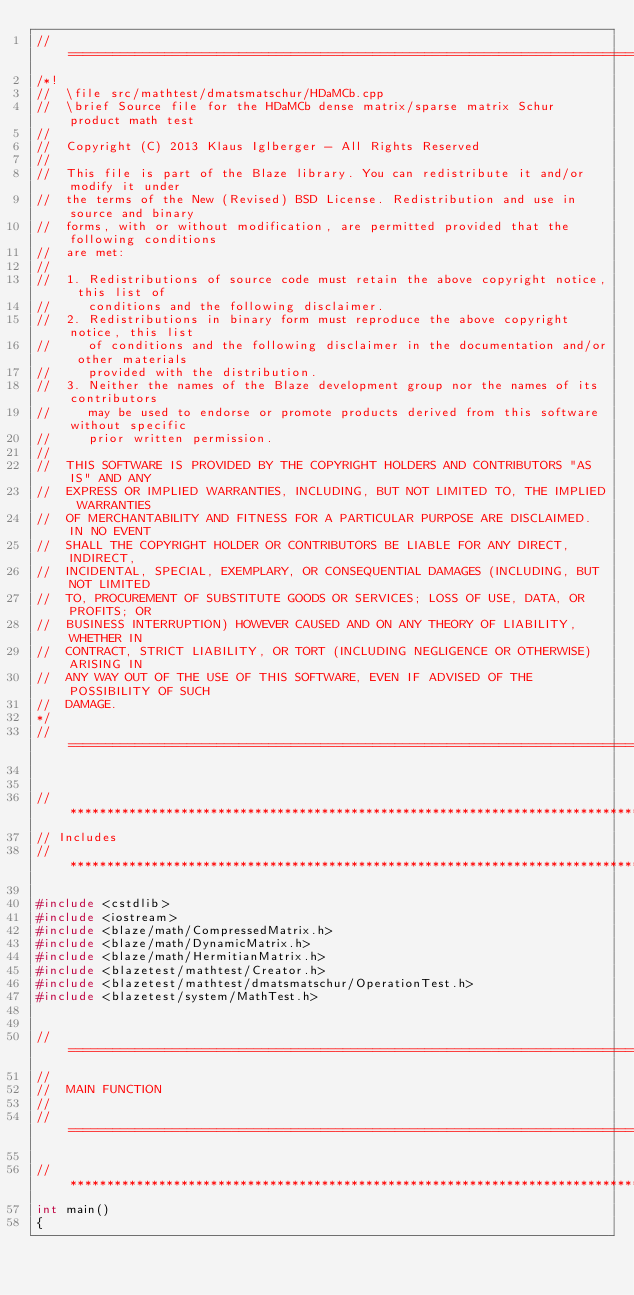<code> <loc_0><loc_0><loc_500><loc_500><_C++_>//=================================================================================================
/*!
//  \file src/mathtest/dmatsmatschur/HDaMCb.cpp
//  \brief Source file for the HDaMCb dense matrix/sparse matrix Schur product math test
//
//  Copyright (C) 2013 Klaus Iglberger - All Rights Reserved
//
//  This file is part of the Blaze library. You can redistribute it and/or modify it under
//  the terms of the New (Revised) BSD License. Redistribution and use in source and binary
//  forms, with or without modification, are permitted provided that the following conditions
//  are met:
//
//  1. Redistributions of source code must retain the above copyright notice, this list of
//     conditions and the following disclaimer.
//  2. Redistributions in binary form must reproduce the above copyright notice, this list
//     of conditions and the following disclaimer in the documentation and/or other materials
//     provided with the distribution.
//  3. Neither the names of the Blaze development group nor the names of its contributors
//     may be used to endorse or promote products derived from this software without specific
//     prior written permission.
//
//  THIS SOFTWARE IS PROVIDED BY THE COPYRIGHT HOLDERS AND CONTRIBUTORS "AS IS" AND ANY
//  EXPRESS OR IMPLIED WARRANTIES, INCLUDING, BUT NOT LIMITED TO, THE IMPLIED WARRANTIES
//  OF MERCHANTABILITY AND FITNESS FOR A PARTICULAR PURPOSE ARE DISCLAIMED. IN NO EVENT
//  SHALL THE COPYRIGHT HOLDER OR CONTRIBUTORS BE LIABLE FOR ANY DIRECT, INDIRECT,
//  INCIDENTAL, SPECIAL, EXEMPLARY, OR CONSEQUENTIAL DAMAGES (INCLUDING, BUT NOT LIMITED
//  TO, PROCUREMENT OF SUBSTITUTE GOODS OR SERVICES; LOSS OF USE, DATA, OR PROFITS; OR
//  BUSINESS INTERRUPTION) HOWEVER CAUSED AND ON ANY THEORY OF LIABILITY, WHETHER IN
//  CONTRACT, STRICT LIABILITY, OR TORT (INCLUDING NEGLIGENCE OR OTHERWISE) ARISING IN
//  ANY WAY OUT OF THE USE OF THIS SOFTWARE, EVEN IF ADVISED OF THE POSSIBILITY OF SUCH
//  DAMAGE.
*/
//=================================================================================================


//*************************************************************************************************
// Includes
//*************************************************************************************************

#include <cstdlib>
#include <iostream>
#include <blaze/math/CompressedMatrix.h>
#include <blaze/math/DynamicMatrix.h>
#include <blaze/math/HermitianMatrix.h>
#include <blazetest/mathtest/Creator.h>
#include <blazetest/mathtest/dmatsmatschur/OperationTest.h>
#include <blazetest/system/MathTest.h>


//=================================================================================================
//
//  MAIN FUNCTION
//
//=================================================================================================

//*************************************************************************************************
int main()
{</code> 